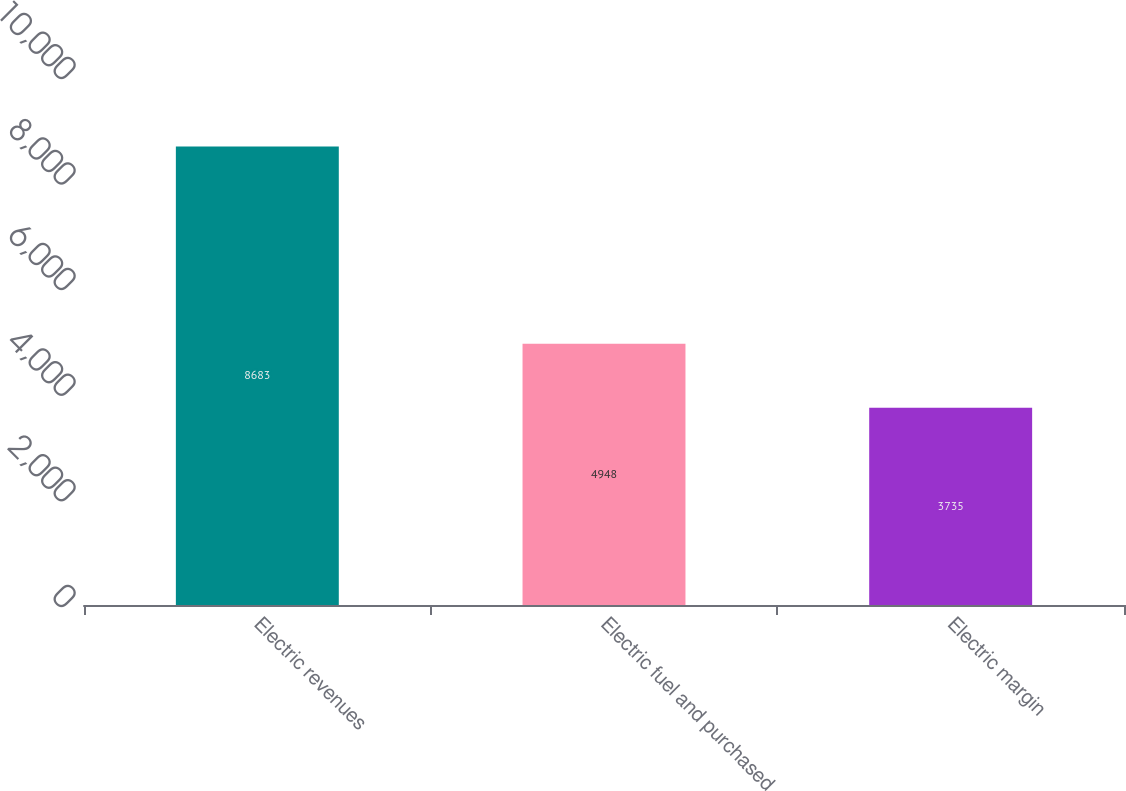Convert chart to OTSL. <chart><loc_0><loc_0><loc_500><loc_500><bar_chart><fcel>Electric revenues<fcel>Electric fuel and purchased<fcel>Electric margin<nl><fcel>8683<fcel>4948<fcel>3735<nl></chart> 